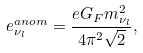Convert formula to latex. <formula><loc_0><loc_0><loc_500><loc_500>e _ { \nu _ { l } } ^ { a n o m } = \frac { e G _ { F } m _ { \nu _ { l } } ^ { 2 } } { 4 \pi ^ { 2 } \sqrt { 2 } } ,</formula> 